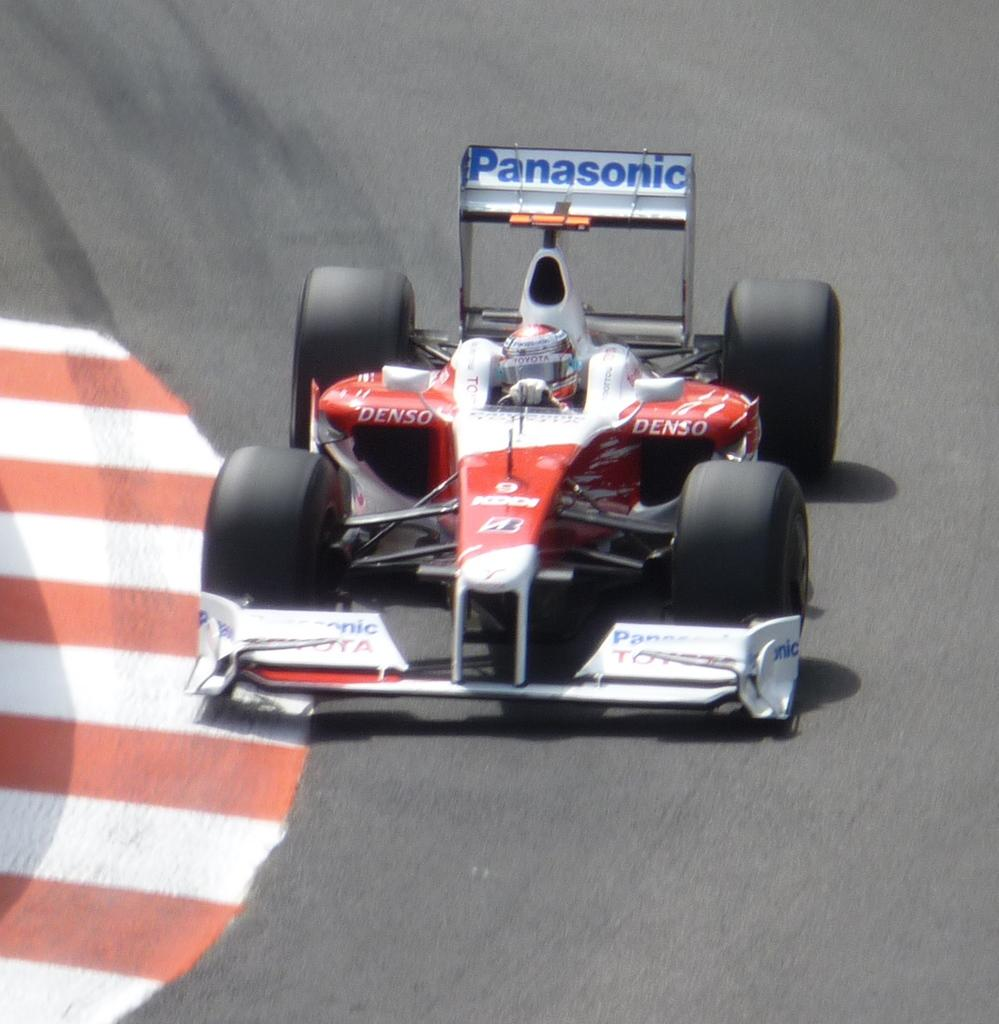What is the main subject of the image? The main subject of the image is a car. Where is the car located in the image? The car is on a racing track. Is the car stuck in quicksand in the image? No, the car is not stuck in quicksand in the image; it is on a racing track. What type of card is being used to play a game in the image? There is no card or game present in the image; it only features a car on a racing track. 